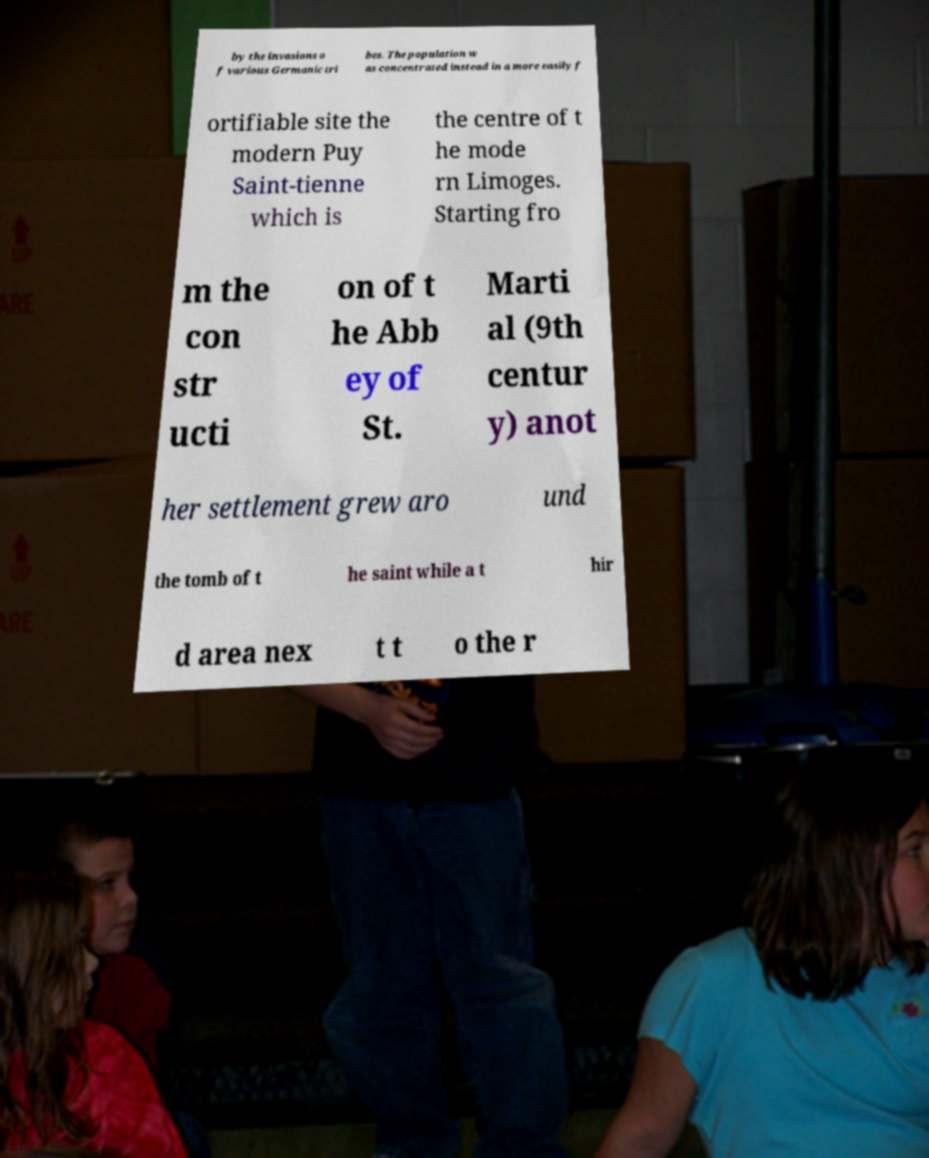I need the written content from this picture converted into text. Can you do that? by the invasions o f various Germanic tri bes. The population w as concentrated instead in a more easily f ortifiable site the modern Puy Saint-tienne which is the centre of t he mode rn Limoges. Starting fro m the con str ucti on of t he Abb ey of St. Marti al (9th centur y) anot her settlement grew aro und the tomb of t he saint while a t hir d area nex t t o the r 